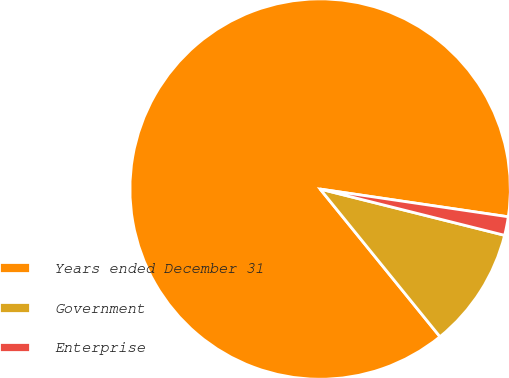<chart> <loc_0><loc_0><loc_500><loc_500><pie_chart><fcel>Years ended December 31<fcel>Government<fcel>Enterprise<nl><fcel>88.18%<fcel>10.24%<fcel>1.58%<nl></chart> 